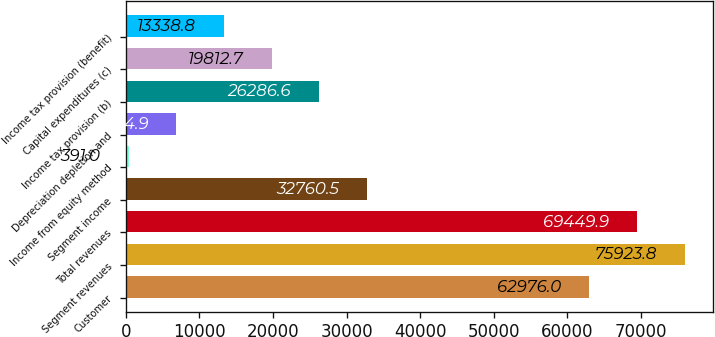Convert chart. <chart><loc_0><loc_0><loc_500><loc_500><bar_chart><fcel>Customer<fcel>Segment revenues<fcel>Total revenues<fcel>Segment income<fcel>Income from equity method<fcel>Depreciation depletion and<fcel>Income tax provision (b)<fcel>Capital expenditures (c)<fcel>Income tax provision (benefit)<nl><fcel>62976<fcel>75923.8<fcel>69449.9<fcel>32760.5<fcel>391<fcel>6864.9<fcel>26286.6<fcel>19812.7<fcel>13338.8<nl></chart> 